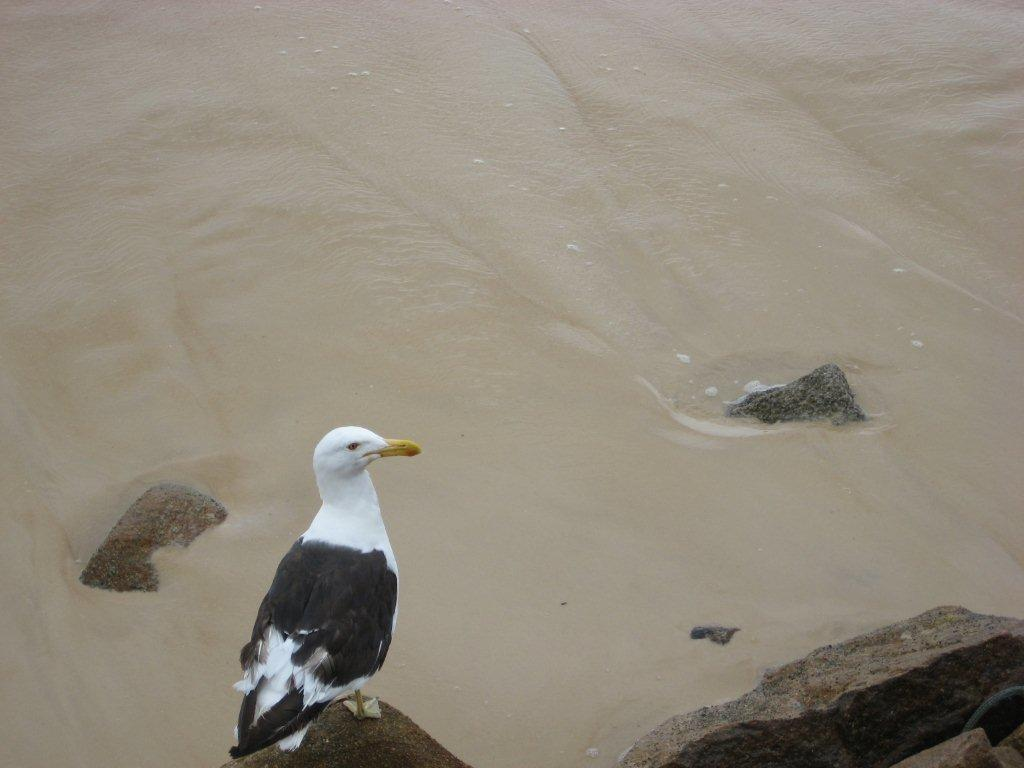What type of animal is in the image? There is a bird in the image. Where is the bird located in relation to the image? The bird is in the front of the image. What can be seen in the background of the image? There is water and stones visible in the background of the image. What type of liquid is the woman using to water the crops in the image? There is no woman or crops present in the image; it features a bird in the front and water and stones in the background. 